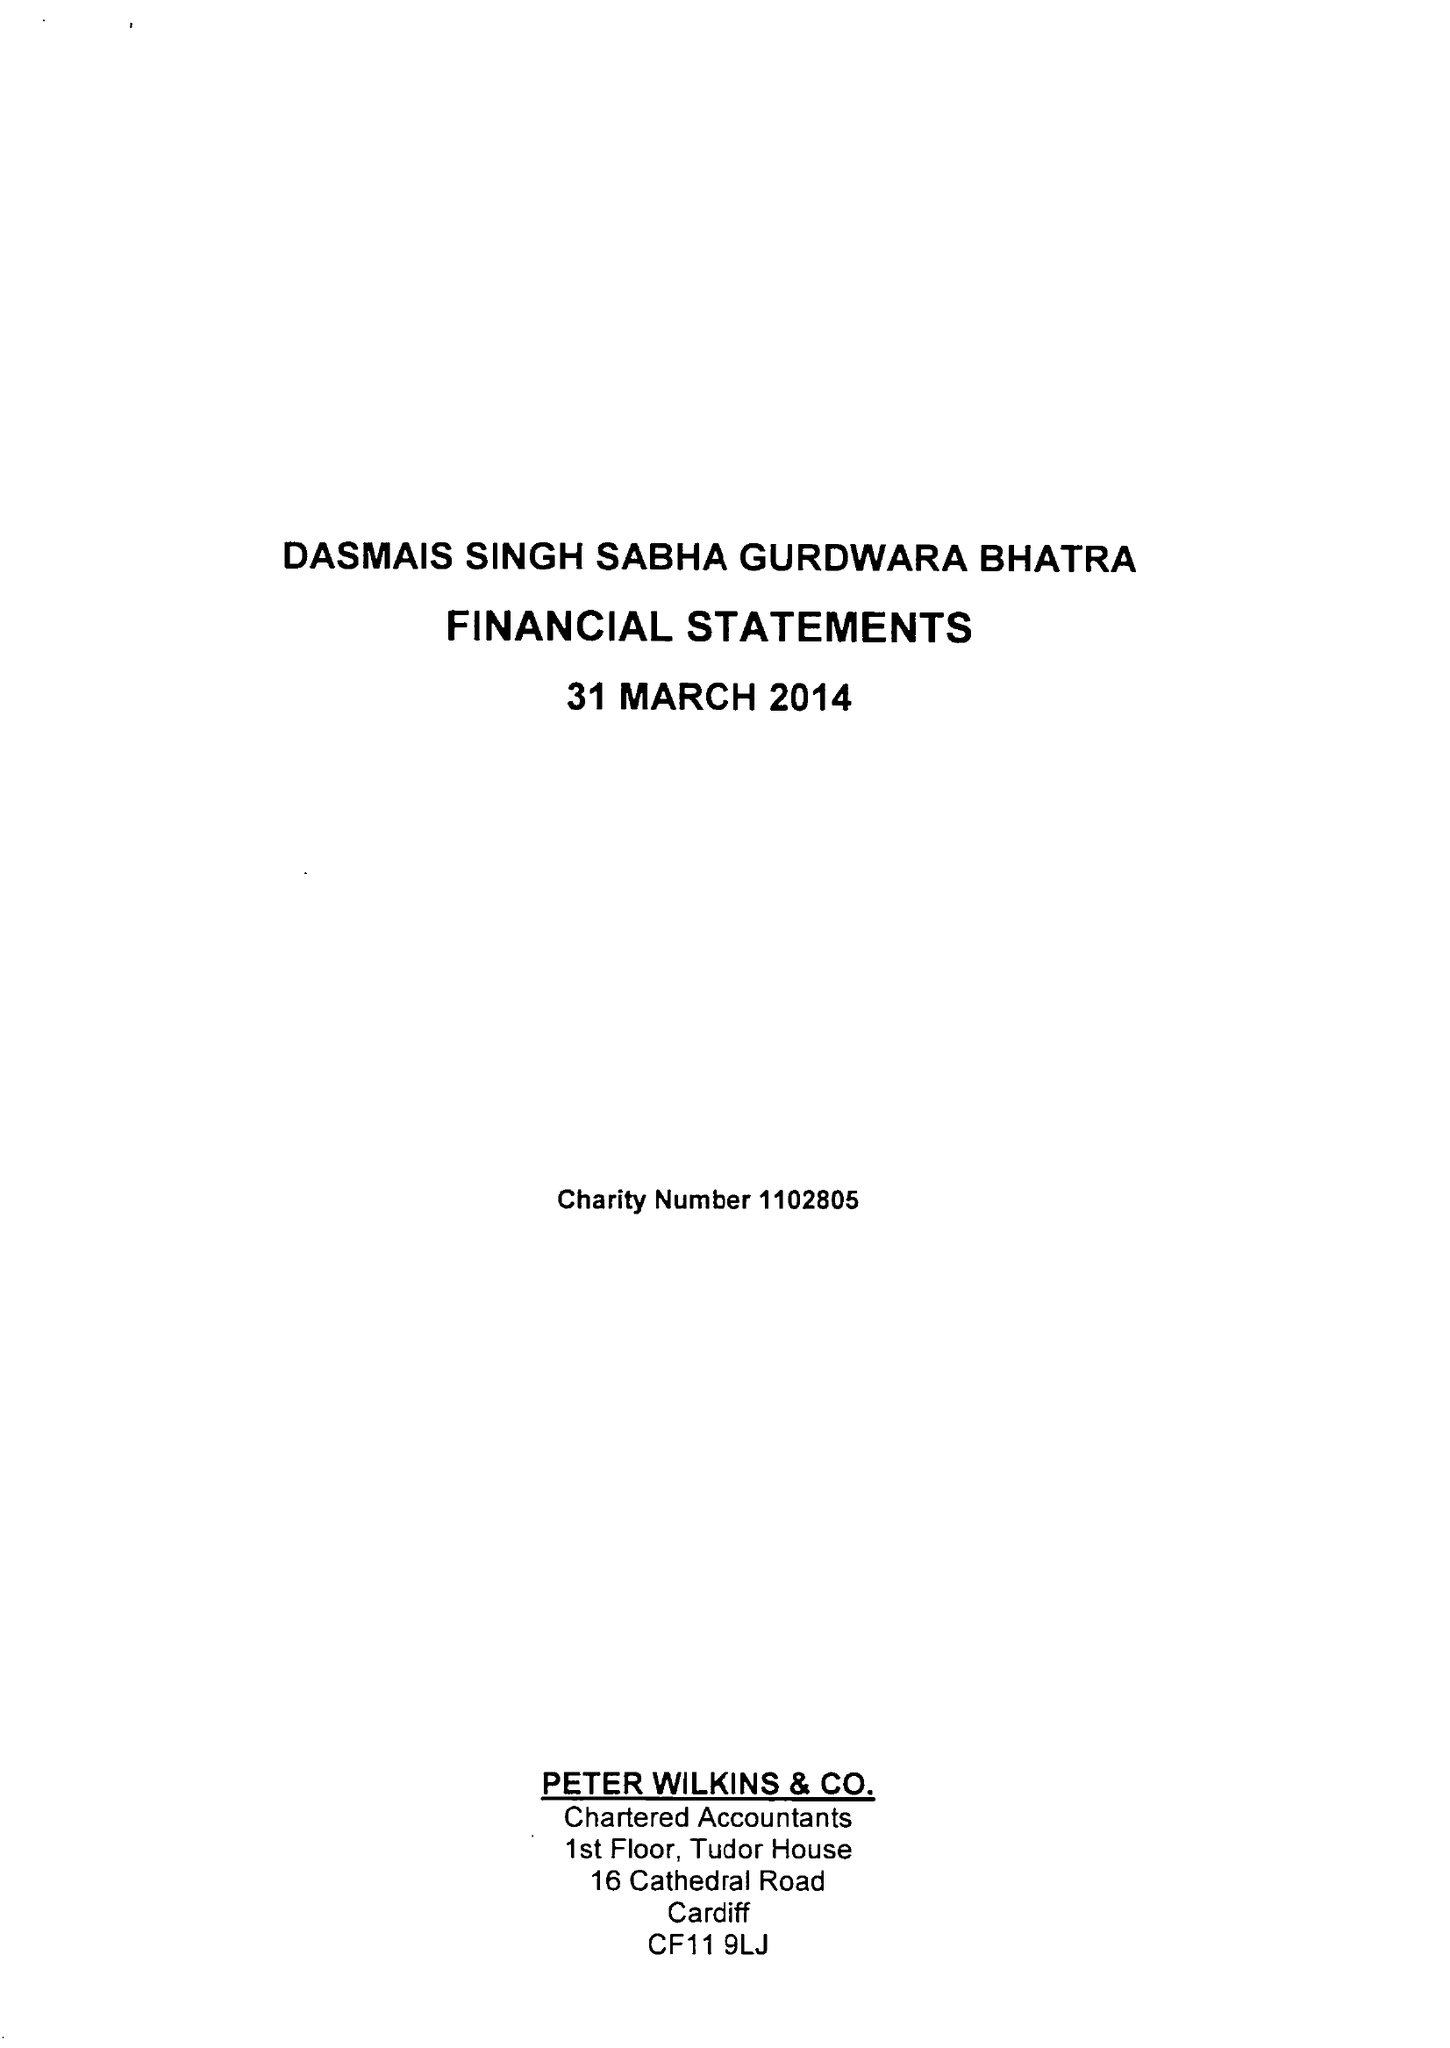What is the value for the address__postcode?
Answer the question using a single word or phrase. CF11 6AE 